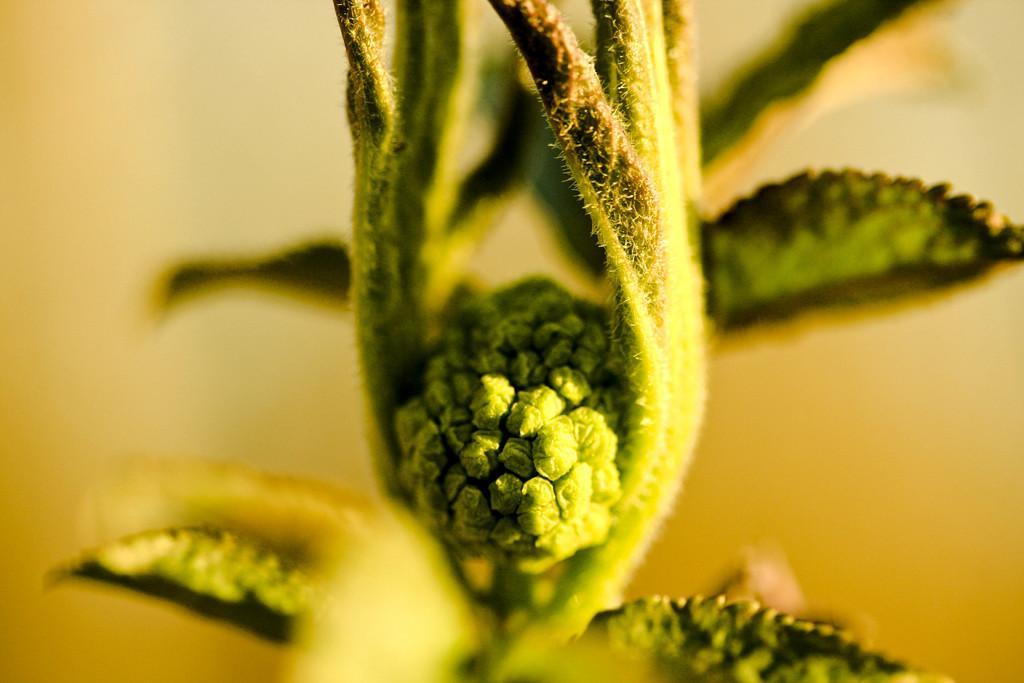What is the main subject of the image? The main subject of the image is a flower bud. Can you describe the location of the flower bud in the image? The flower bud is in the middle of the image. What color can be seen in the background of the image? There is yellow color visible in the background of the image. How many crackers are hanging from the tree in the image? There is no tree or crackers present in the image; it features a flower bud and a yellow background. Can you describe the cow's behavior in the image? There is no cow present in the image. 